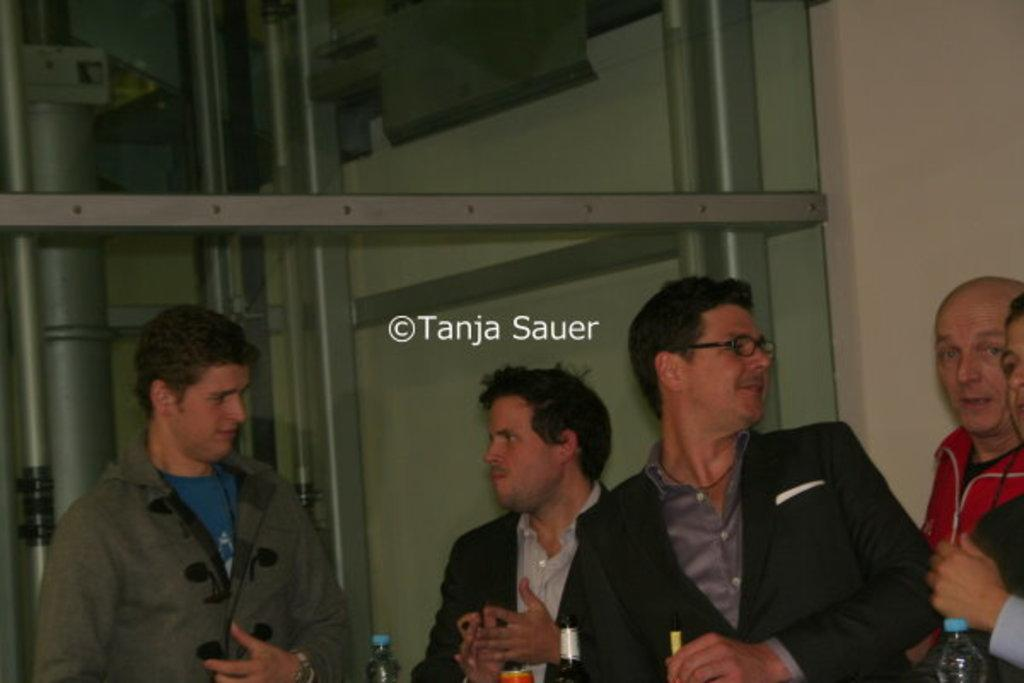How many people are present in the image? There are five people standing in the image. What can be seen in front of the people? There are bottles in front of the people. What type of floor can be seen in the image? The image does not show the floor; it only shows the five people standing and the bottles in front of them. 